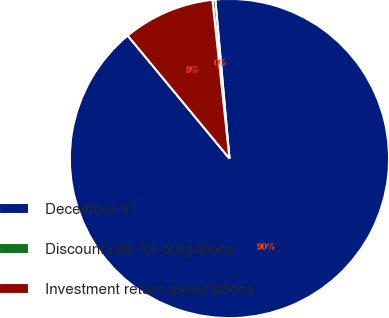Convert chart to OTSL. <chart><loc_0><loc_0><loc_500><loc_500><pie_chart><fcel>December 31<fcel>Discount rate for obligations<fcel>Investment return assumptions<nl><fcel>90.4%<fcel>0.29%<fcel>9.3%<nl></chart> 